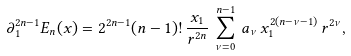Convert formula to latex. <formula><loc_0><loc_0><loc_500><loc_500>\partial _ { 1 } ^ { 2 n - 1 } E _ { n } ( x ) = 2 ^ { 2 n - 1 } ( n - 1 ) ! \, \frac { x _ { 1 } } { r ^ { 2 n } } \, \sum _ { \nu = 0 } ^ { n - 1 } \, a _ { \nu } \, x _ { 1 } ^ { 2 ( n - \nu - 1 ) } \, r ^ { 2 \nu } ,</formula> 